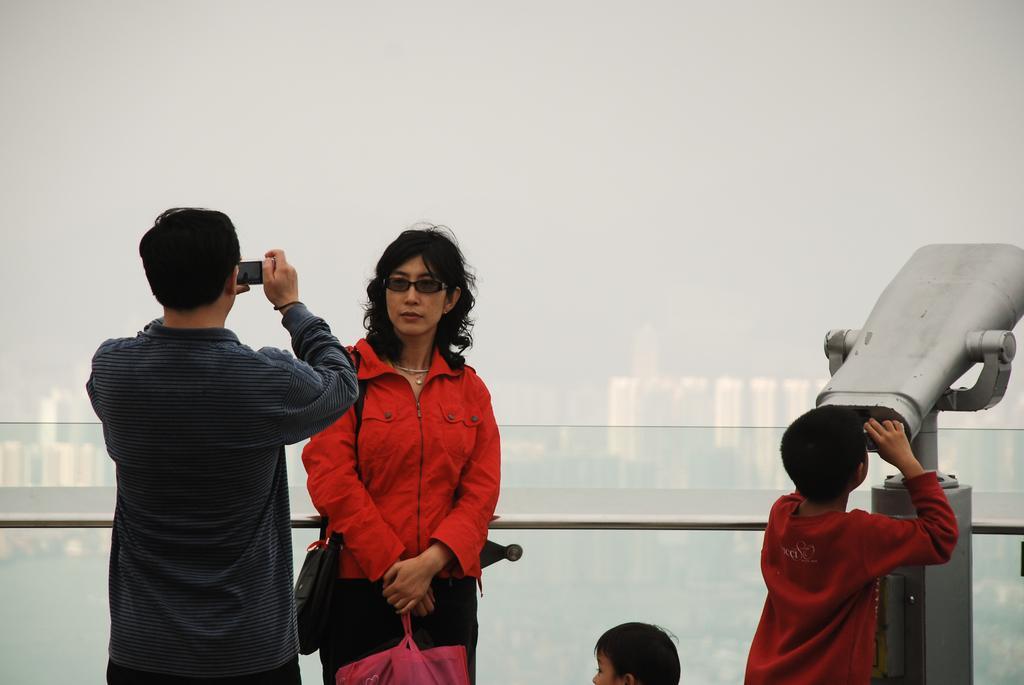Please provide a concise description of this image. In the image there is a man standing and holding an object in his hand. In front of him there is a lady with red jacket is standing. On the right side of the image there is a boy with red t-shirt is standing and holding the object and seeing. And also there is a kid. Behind them there is a rod and railing. And in the background there are buildings. 